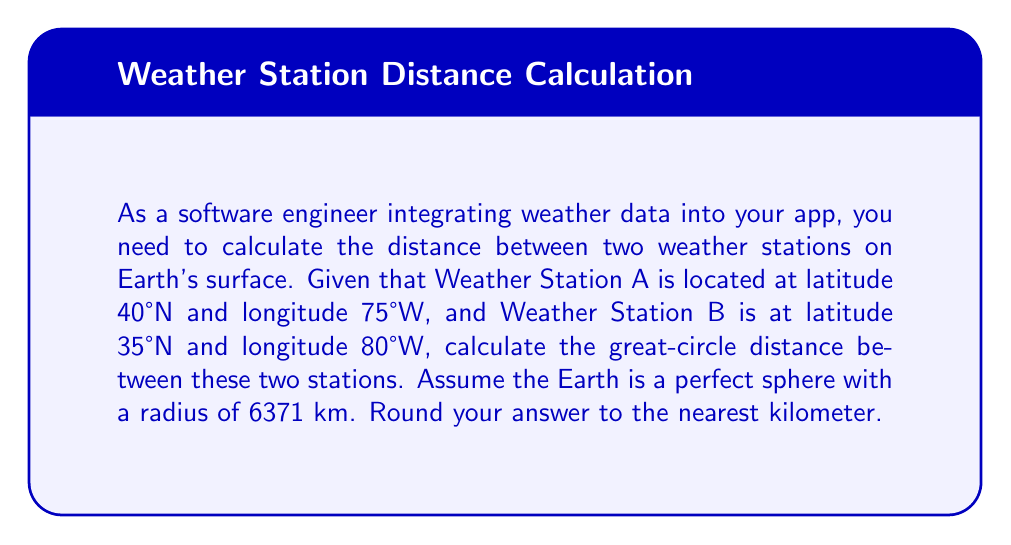Could you help me with this problem? To solve this problem, we'll use the Haversine formula, which calculates the great-circle distance between two points on a sphere given their latitudes and longitudes. Here's the step-by-step solution:

1. Convert the latitudes and longitudes from degrees to radians:
   $$\text{lat}_1 = 40° \cdot \frac{\pi}{180} = 0.6981 \text{ rad}$$
   $$\text{lon}_1 = -75° \cdot \frac{\pi}{180} = -1.3090 \text{ rad}$$
   $$\text{lat}_2 = 35° \cdot \frac{\pi}{180} = 0.6109 \text{ rad}$$
   $$\text{lon}_2 = -80° \cdot \frac{\pi}{180} = -1.3963 \text{ rad}$$

2. Calculate the difference in latitude and longitude:
   $$\Delta\text{lat} = \text{lat}_2 - \text{lat}_1 = 0.6109 - 0.6981 = -0.0872 \text{ rad}$$
   $$\Delta\text{lon} = \text{lon}_2 - \text{lon}_1 = -1.3963 - (-1.3090) = -0.0873 \text{ rad}$$

3. Apply the Haversine formula:
   $$a = \sin^2(\frac{\Delta\text{lat}}{2}) + \cos(\text{lat}_1) \cdot \cos(\text{lat}_2) \cdot \sin^2(\frac{\Delta\text{lon}}{2})$$
   $$c = 2 \cdot \arctan2(\sqrt{a}, \sqrt{1-a})$$
   $$d = R \cdot c$$

   Where $R$ is the Earth's radius (6371 km).

4. Calculate $a$:
   $$a = \sin^2(-0.0436) + \cos(0.6981) \cdot \cos(0.6109) \cdot \sin^2(-0.04365) = 0.0020$$

5. Calculate $c$:
   $$c = 2 \cdot \arctan2(\sqrt{0.0020}, \sqrt{1-0.0020}) = 0.0891$$

6. Calculate the distance $d$:
   $$d = 6371 \cdot 0.0891 = 567.6561 \text{ km}$$

7. Round to the nearest kilometer:
   $$d \approx 568 \text{ km}$$
Answer: 568 km 